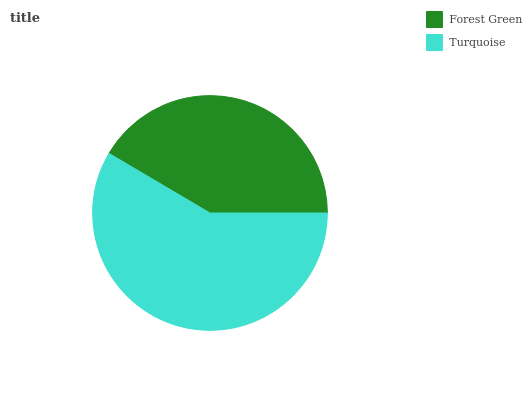Is Forest Green the minimum?
Answer yes or no. Yes. Is Turquoise the maximum?
Answer yes or no. Yes. Is Turquoise the minimum?
Answer yes or no. No. Is Turquoise greater than Forest Green?
Answer yes or no. Yes. Is Forest Green less than Turquoise?
Answer yes or no. Yes. Is Forest Green greater than Turquoise?
Answer yes or no. No. Is Turquoise less than Forest Green?
Answer yes or no. No. Is Turquoise the high median?
Answer yes or no. Yes. Is Forest Green the low median?
Answer yes or no. Yes. Is Forest Green the high median?
Answer yes or no. No. Is Turquoise the low median?
Answer yes or no. No. 